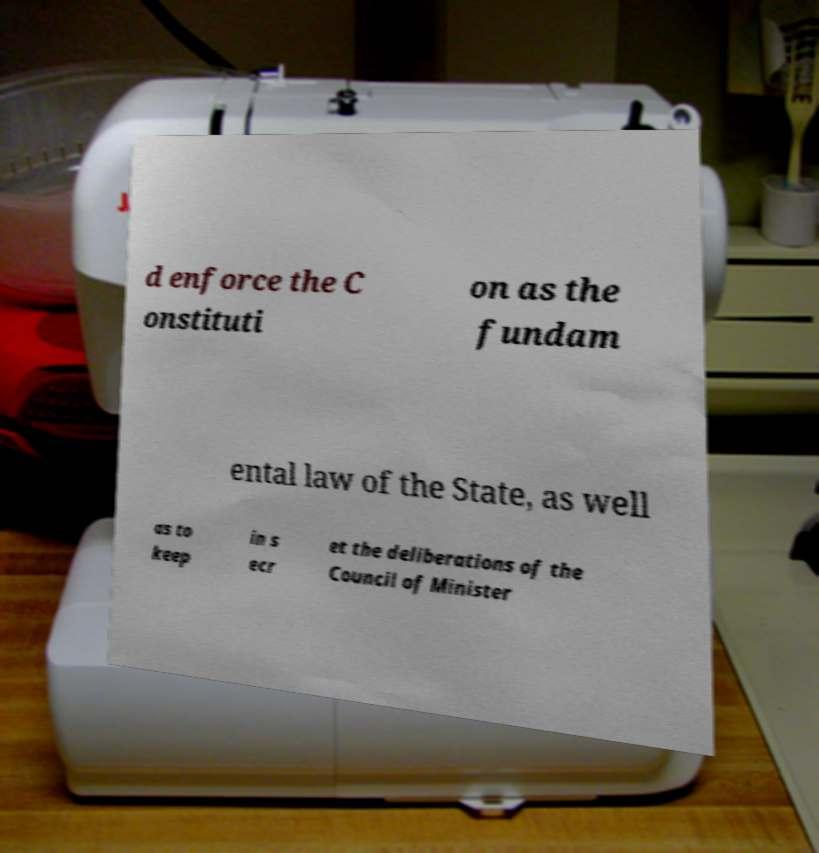Could you assist in decoding the text presented in this image and type it out clearly? d enforce the C onstituti on as the fundam ental law of the State, as well as to keep in s ecr et the deliberations of the Council of Minister 